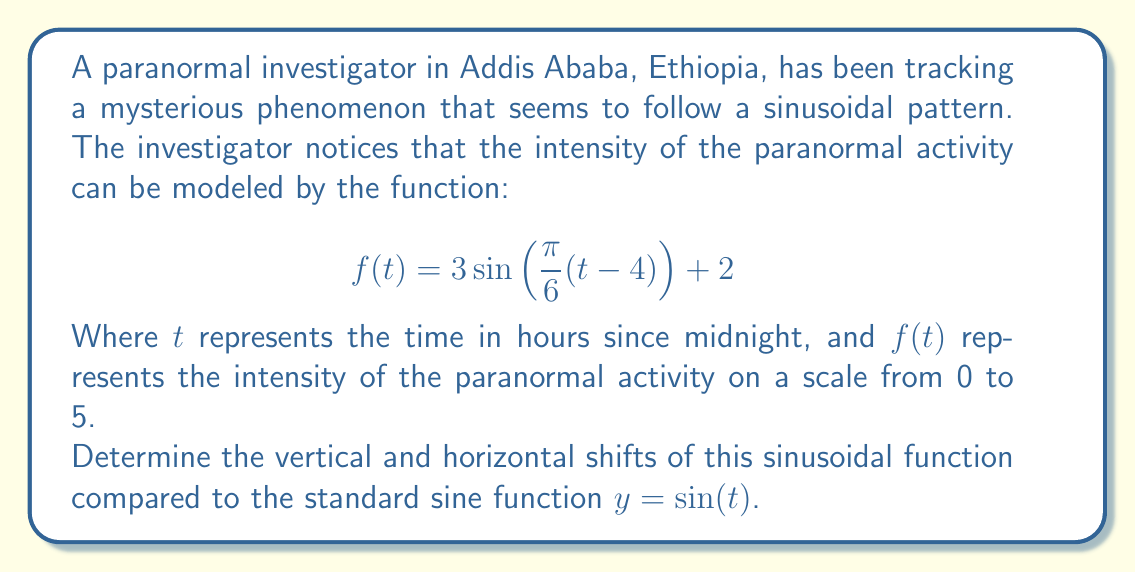What is the answer to this math problem? To determine the vertical and horizontal shifts, we need to compare the given function to the standard form of a sinusoidal function:

$$ y = A\sin(B(t-C)) + D $$

Where:
- $A$ is the amplitude
- $B$ is the frequency
- $C$ is the horizontal shift
- $D$ is the vertical shift

Let's break down our given function:

$$ f(t) = 3\sin\left(\frac{\pi}{6}(t-4)\right) + 2 $$

1. Vertical shift:
   The vertical shift is represented by the constant term added at the end of the function. In this case, it's $+2$. This means the function is shifted 2 units upward compared to the standard sine function.

2. Horizontal shift:
   To find the horizontal shift, we need to look at the term inside the parentheses: $(t-4)$
   The horizontal shift is represented by the constant subtracted from $t$. In this case, it's 4.
   However, we need to be careful about the direction of the shift. When we see $(t-4)$, it means the graph is shifted 4 units to the right.

3. Additional notes:
   - The amplitude of this function is 3, which affects the vertical stretch but not the shift.
   - The frequency is $\frac{\pi}{6}$, which affects the horizontal stretch but not the shift.

In summary:
- Vertical shift: 2 units upward
- Horizontal shift: 4 units to the right
Answer: Vertical shift: 2 units upward
Horizontal shift: 4 units to the right 